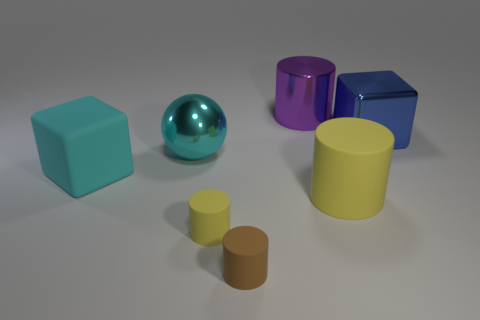What number of matte objects are behind the small yellow cylinder and to the right of the small yellow matte thing?
Give a very brief answer. 1. Is there a small rubber object of the same color as the big shiny cylinder?
Ensure brevity in your answer.  No. The yellow rubber object that is the same size as the brown rubber cylinder is what shape?
Offer a very short reply. Cylinder. There is a cyan metal sphere; are there any big blue things in front of it?
Your response must be concise. No. Is the small cylinder that is behind the tiny brown rubber object made of the same material as the big block that is on the right side of the rubber cube?
Provide a succinct answer. No. What number of blue metallic objects are the same size as the purple object?
Your answer should be compact. 1. There is a rubber thing that is the same color as the big matte cylinder; what is its shape?
Offer a very short reply. Cylinder. There is a big cube on the right side of the purple shiny thing; what material is it?
Your answer should be very brief. Metal. How many cyan matte things have the same shape as the large purple metallic thing?
Your response must be concise. 0. The large cyan thing that is the same material as the small brown object is what shape?
Ensure brevity in your answer.  Cube. 